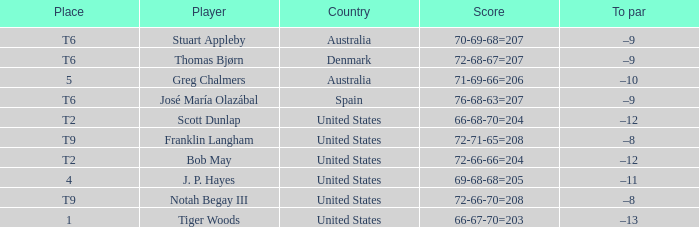What is the place of the player with a 72-71-65=208 score? T9. 